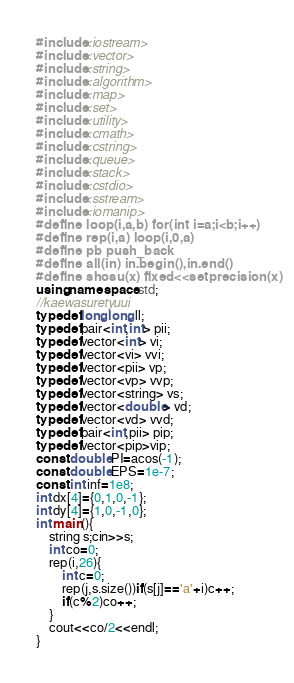<code> <loc_0><loc_0><loc_500><loc_500><_C++_>#include<iostream>
#include<vector>
#include<string>
#include<algorithm>	
#include<map>
#include<set>
#include<utility>
#include<cmath>
#include<cstring>
#include<queue>
#include<stack>
#include<cstdio>
#include<sstream>
#include<iomanip>
#define loop(i,a,b) for(int i=a;i<b;i++) 
#define rep(i,a) loop(i,0,a)
#define pb push_back
#define all(in) in.begin(),in.end()
#define shosu(x) fixed<<setprecision(x)
using namespace std;
//kaewasuretyuui
typedef long long ll;
typedef pair<int,int> pii;
typedef vector<int> vi;
typedef vector<vi> vvi;
typedef vector<pii> vp;
typedef vector<vp> vvp;
typedef vector<string> vs;
typedef vector<double> vd;
typedef vector<vd> vvd;
typedef pair<int,pii> pip;
typedef vector<pip>vip;
const double PI=acos(-1);
const double EPS=1e-7;
const int inf=1e8;
int dx[4]={0,1,0,-1};
int dy[4]={1,0,-1,0};
int main(){
	string s;cin>>s;
	int co=0;
	rep(i,26){
		int c=0;
		rep(j,s.size())if(s[j]=='a'+i)c++;
		if(c%2)co++;
	}
	cout<<co/2<<endl;
}</code> 